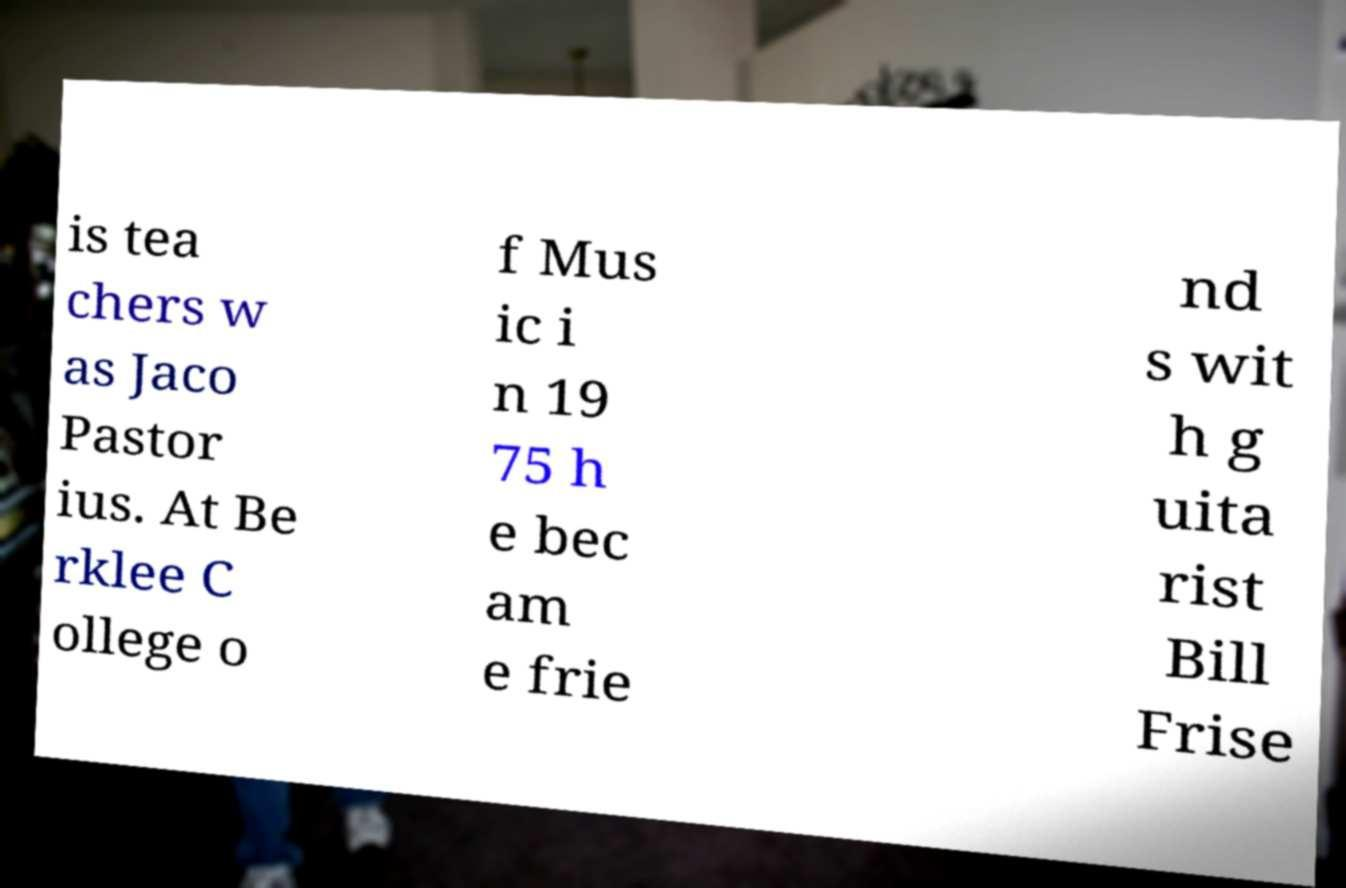Could you extract and type out the text from this image? is tea chers w as Jaco Pastor ius. At Be rklee C ollege o f Mus ic i n 19 75 h e bec am e frie nd s wit h g uita rist Bill Frise 